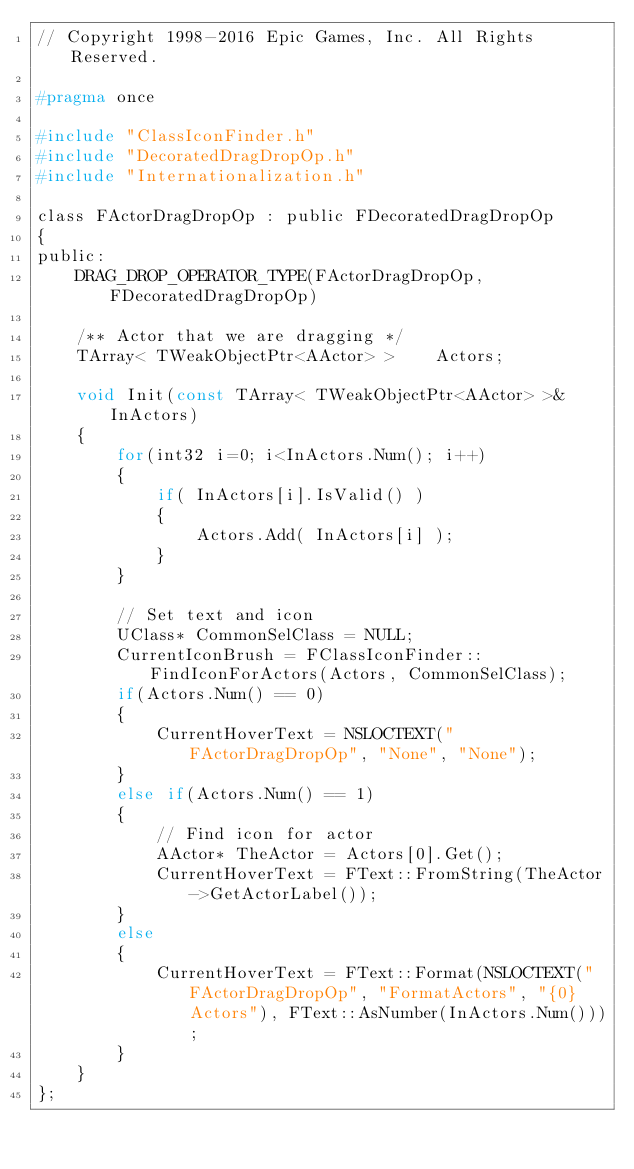<code> <loc_0><loc_0><loc_500><loc_500><_C_>// Copyright 1998-2016 Epic Games, Inc. All Rights Reserved.

#pragma once

#include "ClassIconFinder.h"
#include "DecoratedDragDropOp.h"
#include "Internationalization.h"

class FActorDragDropOp : public FDecoratedDragDropOp
{
public:
	DRAG_DROP_OPERATOR_TYPE(FActorDragDropOp, FDecoratedDragDropOp)

	/** Actor that we are dragging */
	TArray< TWeakObjectPtr<AActor> >	Actors;

	void Init(const TArray< TWeakObjectPtr<AActor> >& InActors)
	{
		for(int32 i=0; i<InActors.Num(); i++)
		{
			if( InActors[i].IsValid() )
			{
				Actors.Add( InActors[i] );
			}
		}

		// Set text and icon
		UClass* CommonSelClass = NULL;
		CurrentIconBrush = FClassIconFinder::FindIconForActors(Actors, CommonSelClass);
		if(Actors.Num() == 0)
		{
			CurrentHoverText = NSLOCTEXT("FActorDragDropOp", "None", "None");
		}
		else if(Actors.Num() == 1)
		{
			// Find icon for actor
			AActor* TheActor = Actors[0].Get();
			CurrentHoverText = FText::FromString(TheActor->GetActorLabel());
		}
		else
		{
			CurrentHoverText = FText::Format(NSLOCTEXT("FActorDragDropOp", "FormatActors", "{0} Actors"), FText::AsNumber(InActors.Num()));
		}
	}
};
</code> 